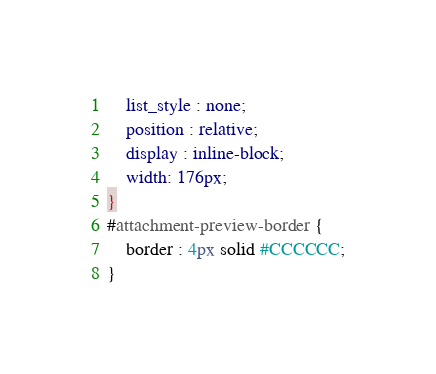<code> <loc_0><loc_0><loc_500><loc_500><_CSS_>	list_style : none;
	position : relative;
	display : inline-block;
	width: 176px;
}
#attachment-preview-border {
	border : 4px solid #CCCCCC;
}</code> 